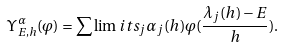Convert formula to latex. <formula><loc_0><loc_0><loc_500><loc_500>\Upsilon ^ { \alpha } _ { E , h } ( \varphi ) = \sum \lim i t s _ { j } \alpha _ { j } ( h ) \varphi ( \frac { \lambda _ { j } ( h ) - E } { h } ) .</formula> 